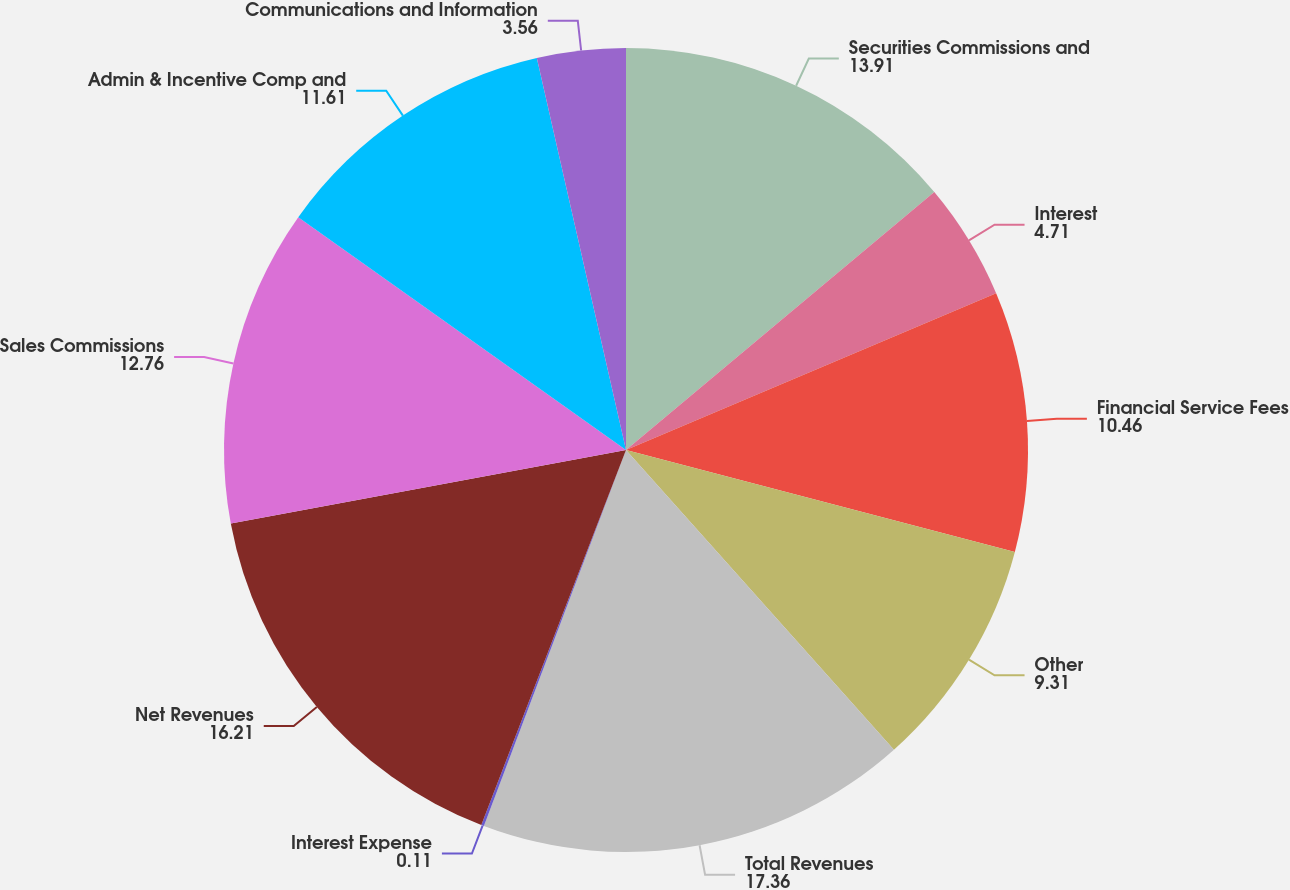Convert chart. <chart><loc_0><loc_0><loc_500><loc_500><pie_chart><fcel>Securities Commissions and<fcel>Interest<fcel>Financial Service Fees<fcel>Other<fcel>Total Revenues<fcel>Interest Expense<fcel>Net Revenues<fcel>Sales Commissions<fcel>Admin & Incentive Comp and<fcel>Communications and Information<nl><fcel>13.91%<fcel>4.71%<fcel>10.46%<fcel>9.31%<fcel>17.36%<fcel>0.11%<fcel>16.21%<fcel>12.76%<fcel>11.61%<fcel>3.56%<nl></chart> 